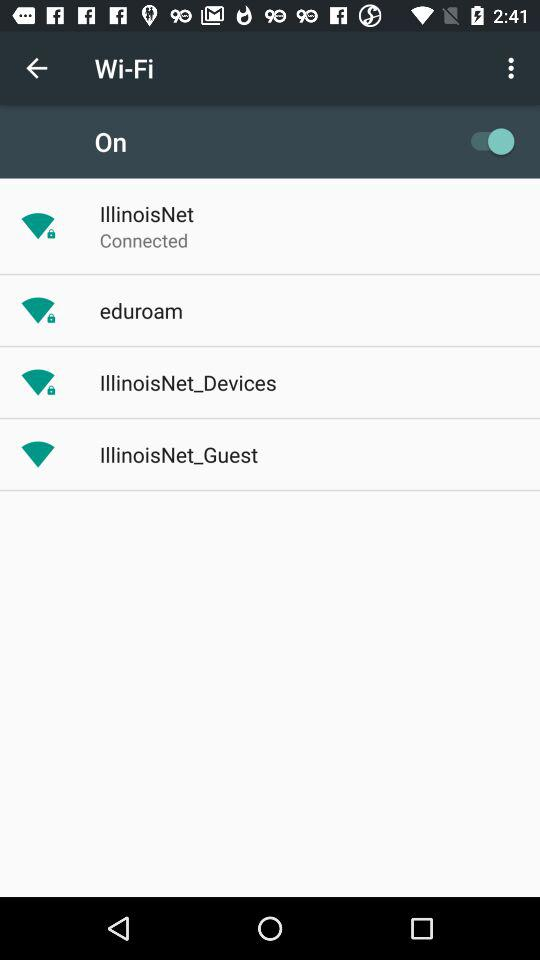Which Wi-Fi network is connected? The connected Wi-Fi network is "IllinoisNet". 